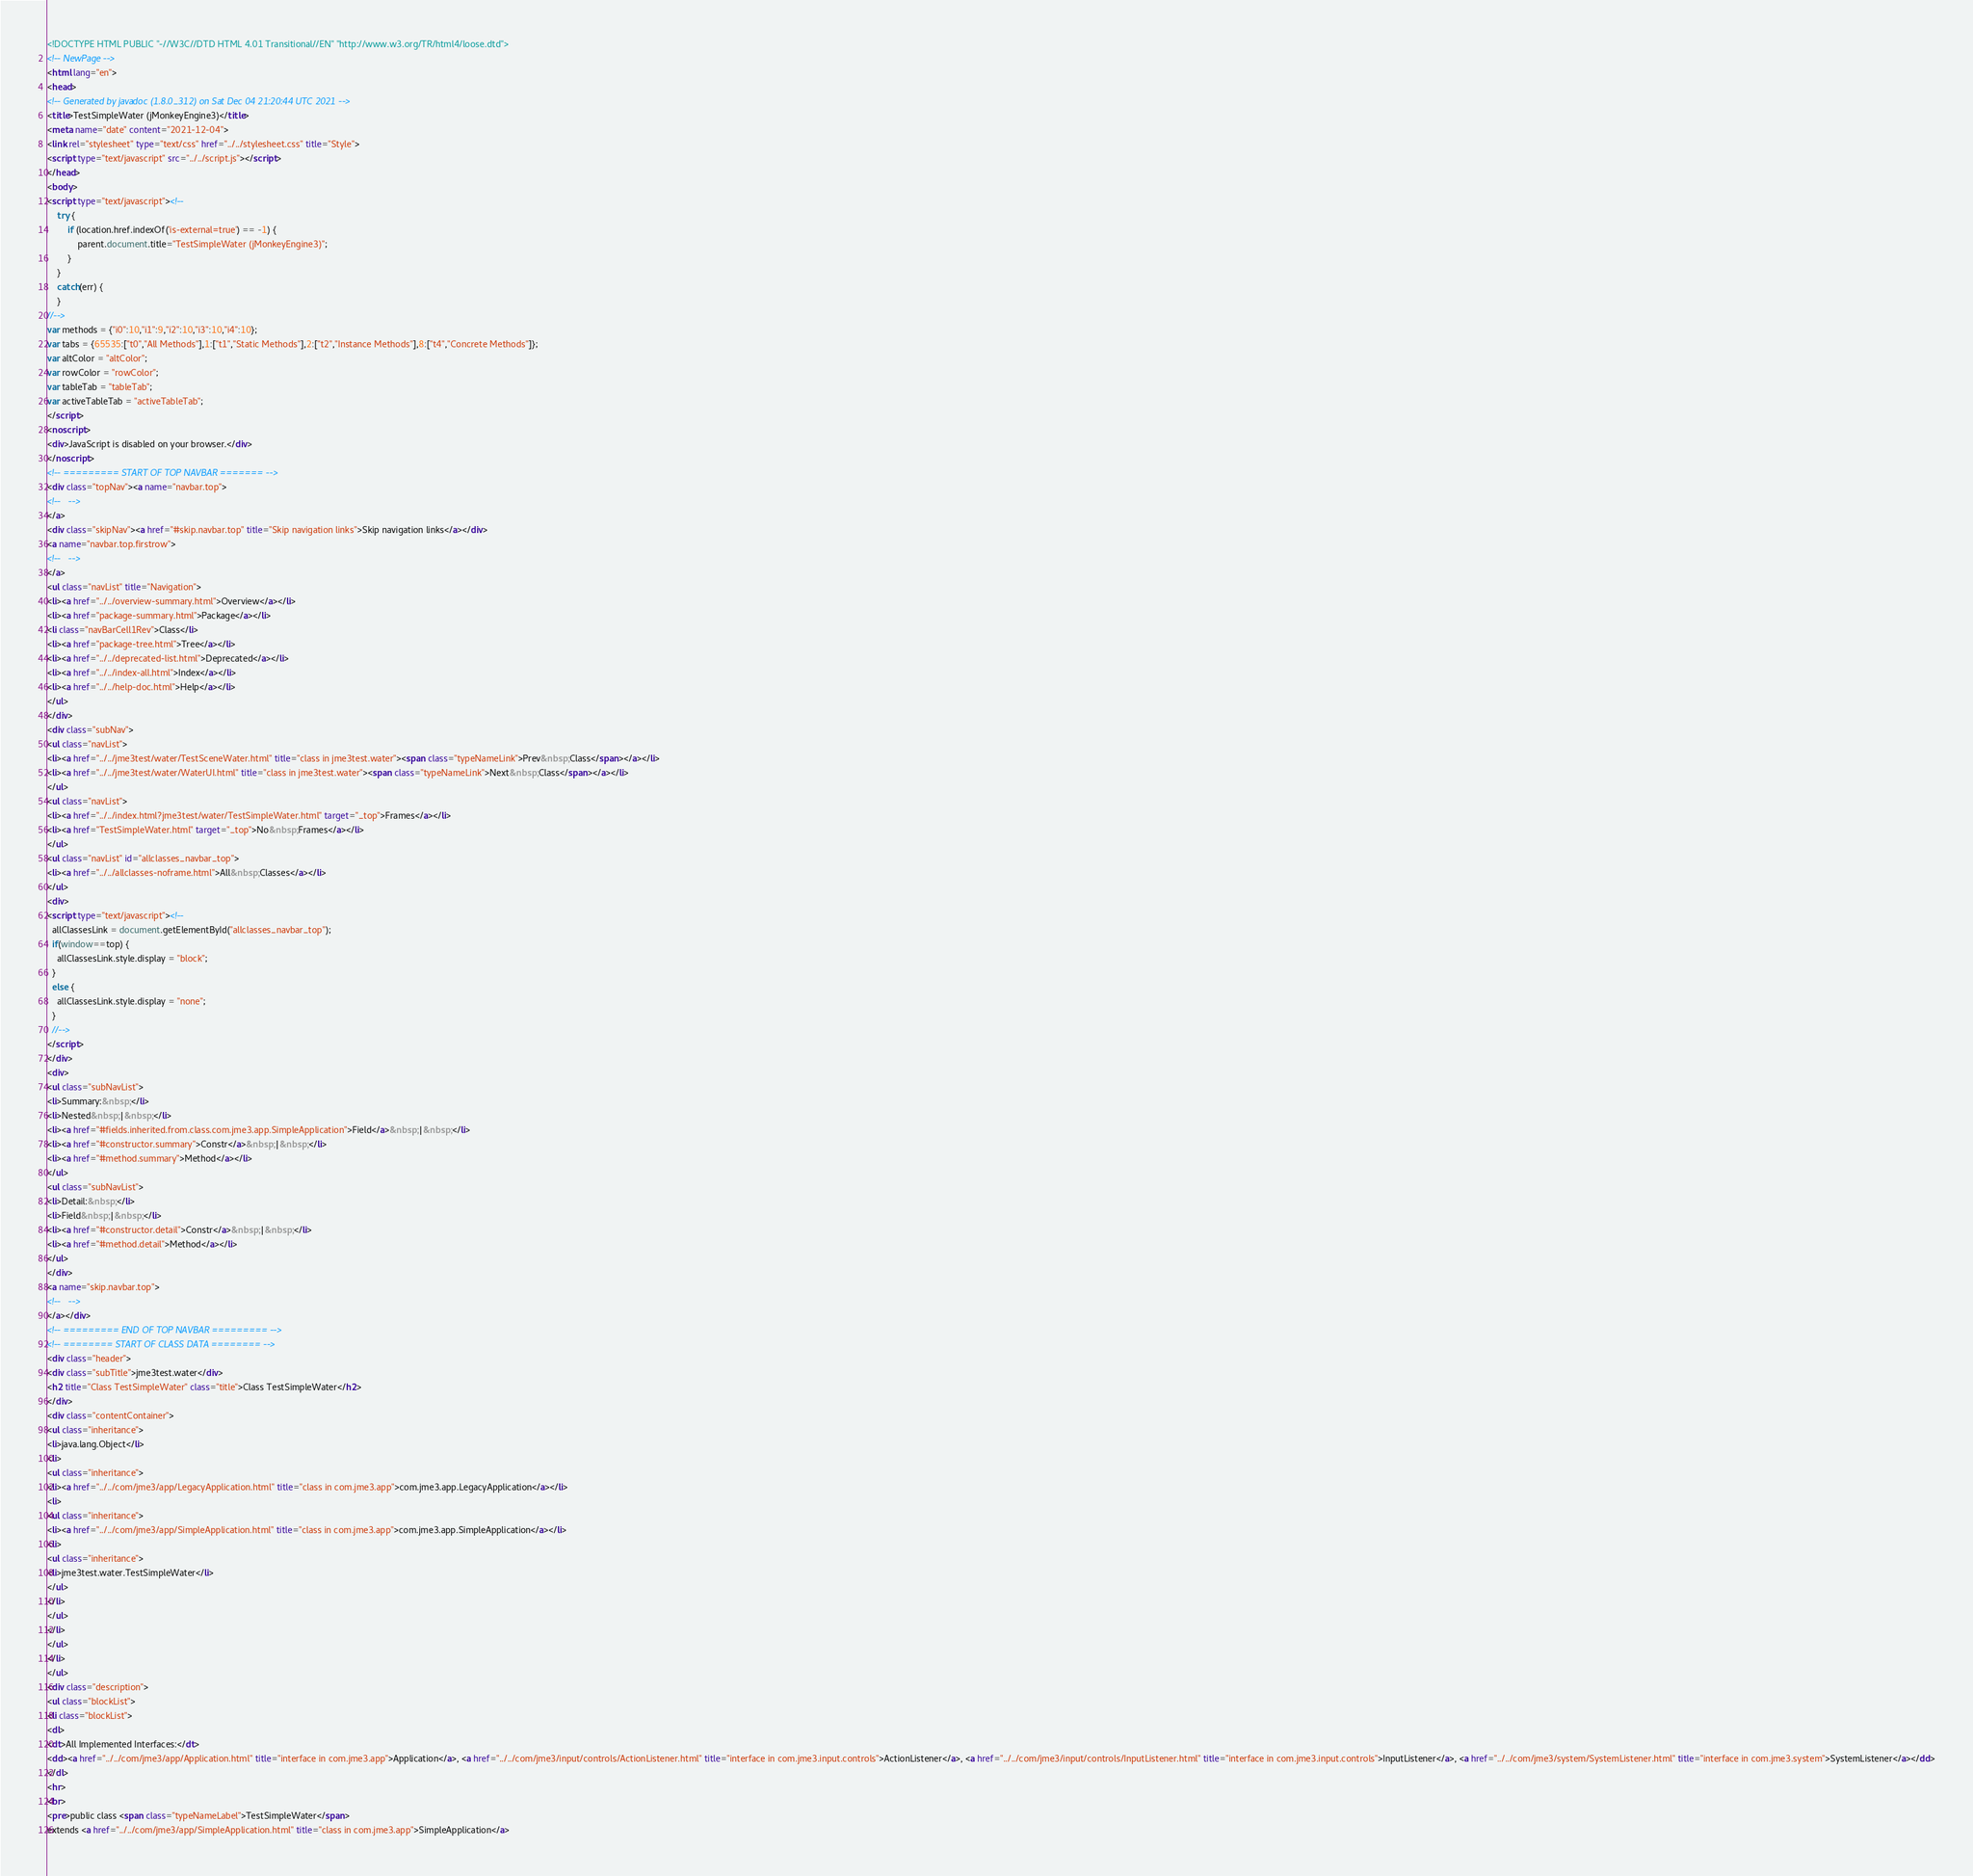<code> <loc_0><loc_0><loc_500><loc_500><_HTML_><!DOCTYPE HTML PUBLIC "-//W3C//DTD HTML 4.01 Transitional//EN" "http://www.w3.org/TR/html4/loose.dtd">
<!-- NewPage -->
<html lang="en">
<head>
<!-- Generated by javadoc (1.8.0_312) on Sat Dec 04 21:20:44 UTC 2021 -->
<title>TestSimpleWater (jMonkeyEngine3)</title>
<meta name="date" content="2021-12-04">
<link rel="stylesheet" type="text/css" href="../../stylesheet.css" title="Style">
<script type="text/javascript" src="../../script.js"></script>
</head>
<body>
<script type="text/javascript"><!--
    try {
        if (location.href.indexOf('is-external=true') == -1) {
            parent.document.title="TestSimpleWater (jMonkeyEngine3)";
        }
    }
    catch(err) {
    }
//-->
var methods = {"i0":10,"i1":9,"i2":10,"i3":10,"i4":10};
var tabs = {65535:["t0","All Methods"],1:["t1","Static Methods"],2:["t2","Instance Methods"],8:["t4","Concrete Methods"]};
var altColor = "altColor";
var rowColor = "rowColor";
var tableTab = "tableTab";
var activeTableTab = "activeTableTab";
</script>
<noscript>
<div>JavaScript is disabled on your browser.</div>
</noscript>
<!-- ========= START OF TOP NAVBAR ======= -->
<div class="topNav"><a name="navbar.top">
<!--   -->
</a>
<div class="skipNav"><a href="#skip.navbar.top" title="Skip navigation links">Skip navigation links</a></div>
<a name="navbar.top.firstrow">
<!--   -->
</a>
<ul class="navList" title="Navigation">
<li><a href="../../overview-summary.html">Overview</a></li>
<li><a href="package-summary.html">Package</a></li>
<li class="navBarCell1Rev">Class</li>
<li><a href="package-tree.html">Tree</a></li>
<li><a href="../../deprecated-list.html">Deprecated</a></li>
<li><a href="../../index-all.html">Index</a></li>
<li><a href="../../help-doc.html">Help</a></li>
</ul>
</div>
<div class="subNav">
<ul class="navList">
<li><a href="../../jme3test/water/TestSceneWater.html" title="class in jme3test.water"><span class="typeNameLink">Prev&nbsp;Class</span></a></li>
<li><a href="../../jme3test/water/WaterUI.html" title="class in jme3test.water"><span class="typeNameLink">Next&nbsp;Class</span></a></li>
</ul>
<ul class="navList">
<li><a href="../../index.html?jme3test/water/TestSimpleWater.html" target="_top">Frames</a></li>
<li><a href="TestSimpleWater.html" target="_top">No&nbsp;Frames</a></li>
</ul>
<ul class="navList" id="allclasses_navbar_top">
<li><a href="../../allclasses-noframe.html">All&nbsp;Classes</a></li>
</ul>
<div>
<script type="text/javascript"><!--
  allClassesLink = document.getElementById("allclasses_navbar_top");
  if(window==top) {
    allClassesLink.style.display = "block";
  }
  else {
    allClassesLink.style.display = "none";
  }
  //-->
</script>
</div>
<div>
<ul class="subNavList">
<li>Summary:&nbsp;</li>
<li>Nested&nbsp;|&nbsp;</li>
<li><a href="#fields.inherited.from.class.com.jme3.app.SimpleApplication">Field</a>&nbsp;|&nbsp;</li>
<li><a href="#constructor.summary">Constr</a>&nbsp;|&nbsp;</li>
<li><a href="#method.summary">Method</a></li>
</ul>
<ul class="subNavList">
<li>Detail:&nbsp;</li>
<li>Field&nbsp;|&nbsp;</li>
<li><a href="#constructor.detail">Constr</a>&nbsp;|&nbsp;</li>
<li><a href="#method.detail">Method</a></li>
</ul>
</div>
<a name="skip.navbar.top">
<!--   -->
</a></div>
<!-- ========= END OF TOP NAVBAR ========= -->
<!-- ======== START OF CLASS DATA ======== -->
<div class="header">
<div class="subTitle">jme3test.water</div>
<h2 title="Class TestSimpleWater" class="title">Class TestSimpleWater</h2>
</div>
<div class="contentContainer">
<ul class="inheritance">
<li>java.lang.Object</li>
<li>
<ul class="inheritance">
<li><a href="../../com/jme3/app/LegacyApplication.html" title="class in com.jme3.app">com.jme3.app.LegacyApplication</a></li>
<li>
<ul class="inheritance">
<li><a href="../../com/jme3/app/SimpleApplication.html" title="class in com.jme3.app">com.jme3.app.SimpleApplication</a></li>
<li>
<ul class="inheritance">
<li>jme3test.water.TestSimpleWater</li>
</ul>
</li>
</ul>
</li>
</ul>
</li>
</ul>
<div class="description">
<ul class="blockList">
<li class="blockList">
<dl>
<dt>All Implemented Interfaces:</dt>
<dd><a href="../../com/jme3/app/Application.html" title="interface in com.jme3.app">Application</a>, <a href="../../com/jme3/input/controls/ActionListener.html" title="interface in com.jme3.input.controls">ActionListener</a>, <a href="../../com/jme3/input/controls/InputListener.html" title="interface in com.jme3.input.controls">InputListener</a>, <a href="../../com/jme3/system/SystemListener.html" title="interface in com.jme3.system">SystemListener</a></dd>
</dl>
<hr>
<br>
<pre>public class <span class="typeNameLabel">TestSimpleWater</span>
extends <a href="../../com/jme3/app/SimpleApplication.html" title="class in com.jme3.app">SimpleApplication</a></code> 